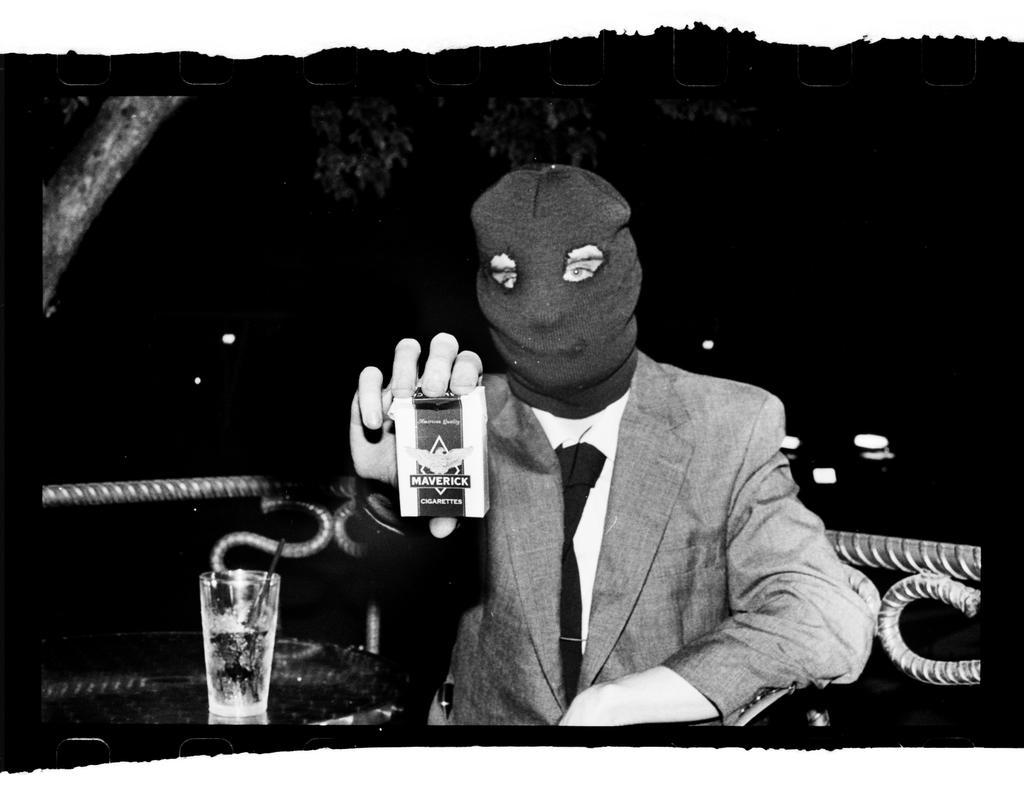Could you give a brief overview of what you see in this image? In this image we can see there is a person sitting on the chair and holding a packet. At the side there is a table, on the table there is a glass with a straw. At the back there is a fence and a tree. And there is a dark background. 